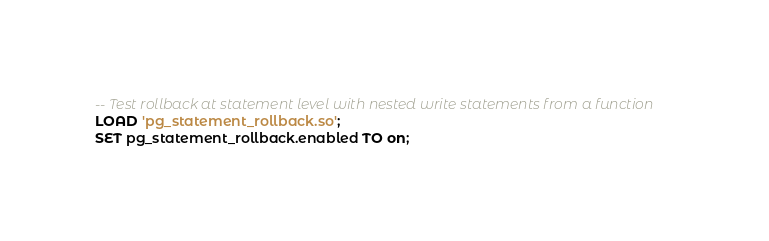<code> <loc_0><loc_0><loc_500><loc_500><_SQL_>-- Test rollback at statement level with nested write statements from a function
LOAD 'pg_statement_rollback.so';
SET pg_statement_rollback.enabled TO on;</code> 